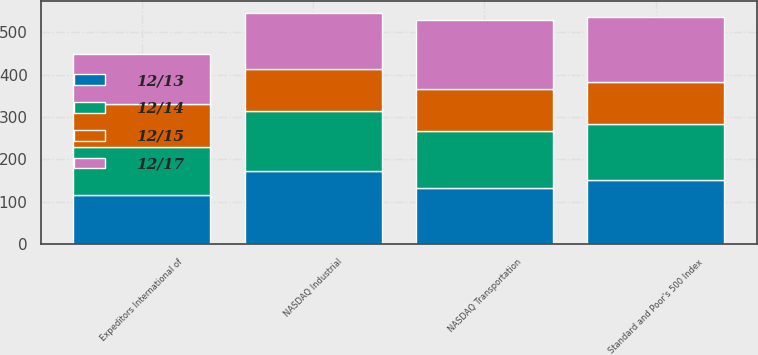Convert chart. <chart><loc_0><loc_0><loc_500><loc_500><stacked_bar_chart><ecel><fcel>Expeditors International of<fcel>Standard and Poor's 500 Index<fcel>NASDAQ Transportation<fcel>NASDAQ Industrial<nl><fcel>12/15<fcel>100<fcel>100<fcel>100<fcel>100<nl><fcel>12/14<fcel>113.52<fcel>132.39<fcel>133.76<fcel>141.6<nl><fcel>12/13<fcel>116.07<fcel>150.51<fcel>132.39<fcel>171.91<nl><fcel>12/17<fcel>119.12<fcel>152.59<fcel>162.3<fcel>132.47<nl></chart> 